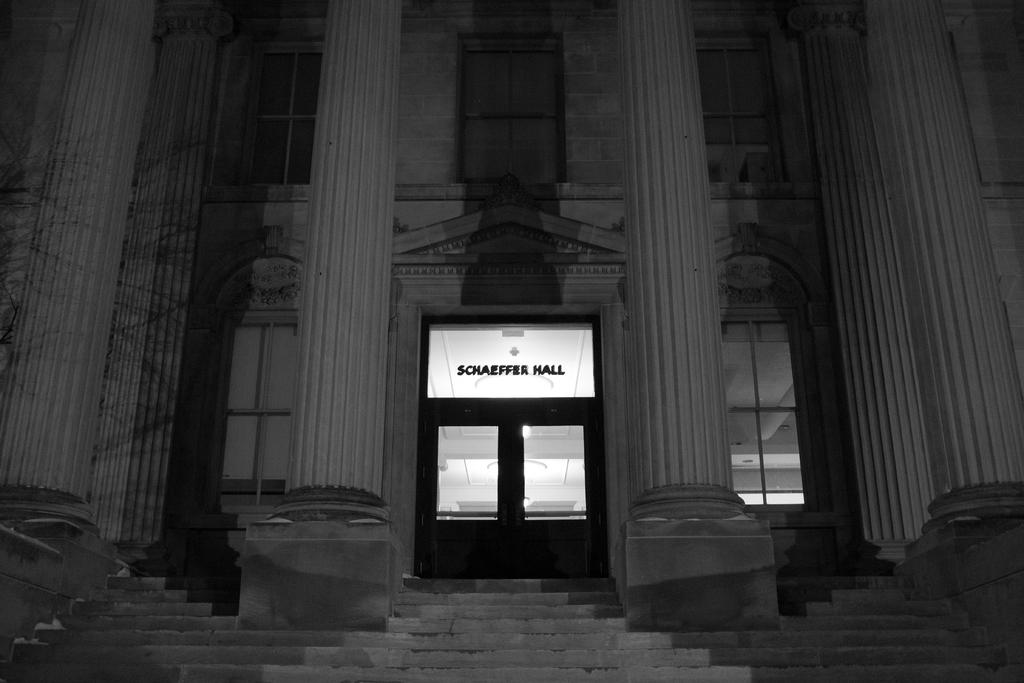What is the color scheme of the image? The image is black and white. What architectural features can be seen in the image? There are pillars in the image. What type of structure is depicted in the image? There is a building in the image. What are some features of the building? The building has windows and a door. What type of lighting is present inside the building? There are ceiling lights inside the building. Where is the shelf located in the image? There is no shelf present in the image. What type of thing is floating in space in the image? There is no thing floating in space in the image; it is a black and white image of a building with pillars and architectural features. 